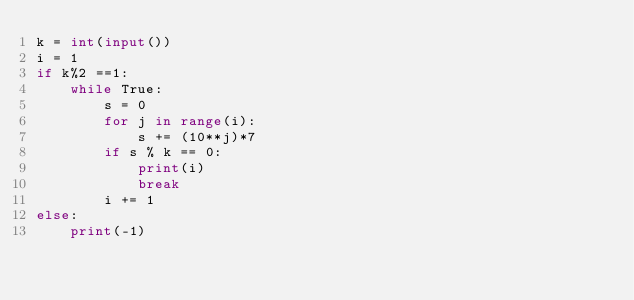Convert code to text. <code><loc_0><loc_0><loc_500><loc_500><_Python_>k = int(input())
i = 1
if k%2 ==1:
    while True:
        s = 0
        for j in range(i):
            s += (10**j)*7
        if s % k == 0:
            print(i)
            break
        i += 1
else:
    print(-1)</code> 